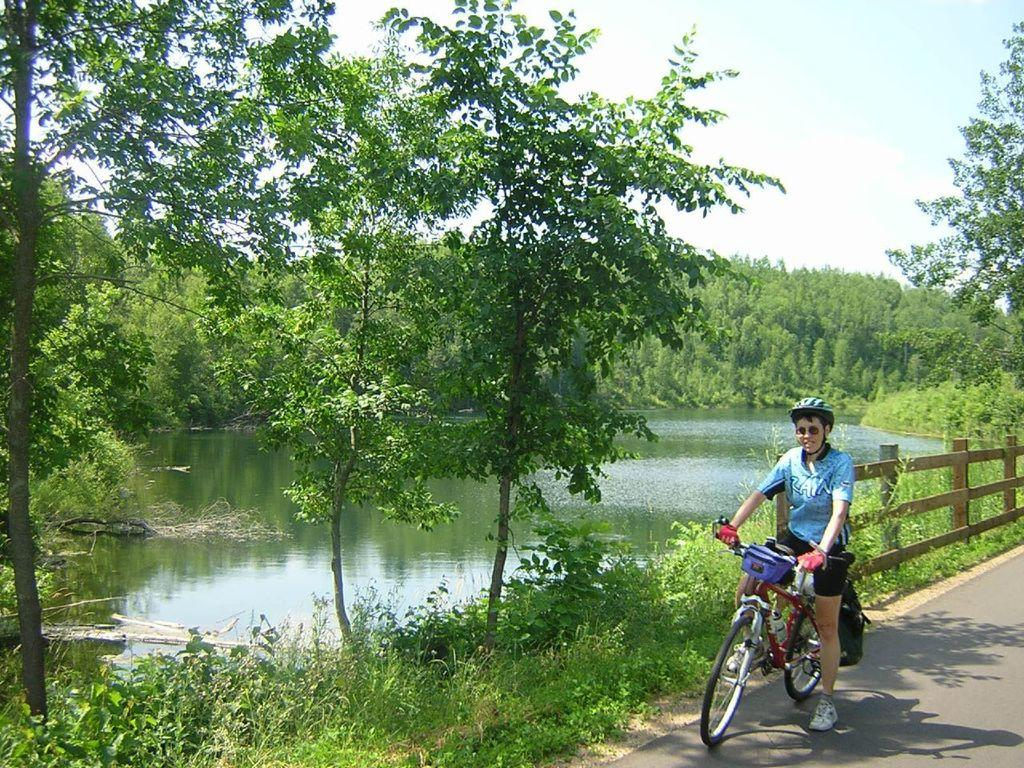What is the person in the image doing? The person is on a cycle in the image. Where is the person located in the image? The person is on a path in the image. What can be seen in the background of the image? There are plants, trees, water, and the sky visible in the background of the image. What type of punishment is the person receiving in the image? There is no indication of punishment in the image; the person is simply riding a cycle on a path. Can you tell me how much honey the person has collected in the image? There is no honey or any indication of honey collection in the image. 